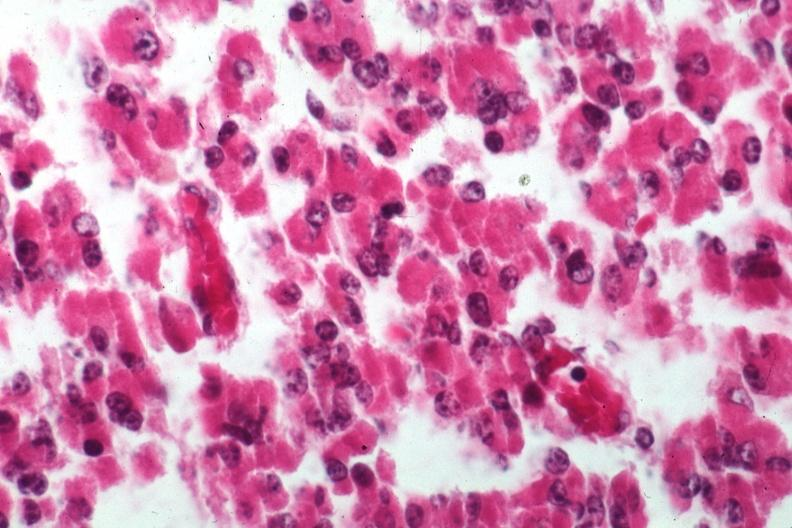what does this image show?
Answer the question using a single word or phrase. Cells of adenoma 